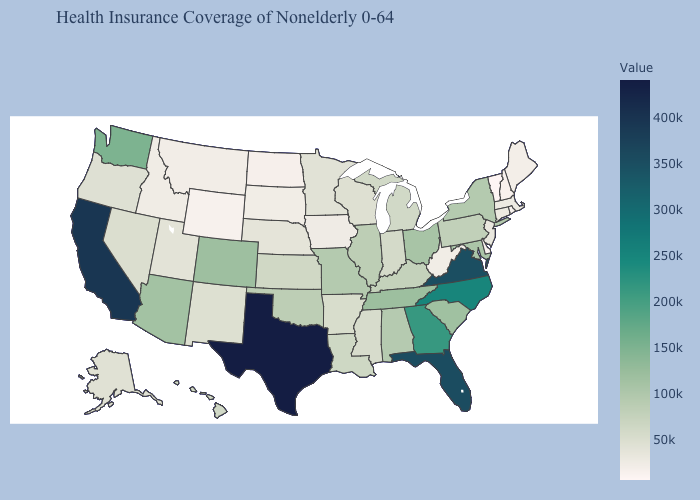Does Vermont have the lowest value in the USA?
Answer briefly. Yes. Which states have the lowest value in the MidWest?
Keep it brief. North Dakota. Which states have the lowest value in the USA?
Short answer required. Vermont. Which states hav the highest value in the Northeast?
Answer briefly. New York. Does Florida have the highest value in the USA?
Short answer required. No. Does Alaska have the highest value in the West?
Short answer required. No. 